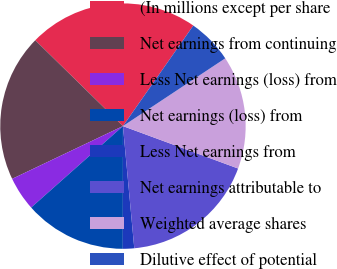Convert chart to OTSL. <chart><loc_0><loc_0><loc_500><loc_500><pie_chart><fcel>(In millions except per share<fcel>Net earnings from continuing<fcel>Less Net earnings (loss) from<fcel>Net earnings (loss) from<fcel>Less Net earnings from<fcel>Net earnings attributable to<fcel>Weighted average shares<fcel>Dilutive effect of potential<nl><fcel>22.39%<fcel>19.4%<fcel>4.48%<fcel>13.43%<fcel>1.49%<fcel>17.91%<fcel>14.93%<fcel>5.97%<nl></chart> 